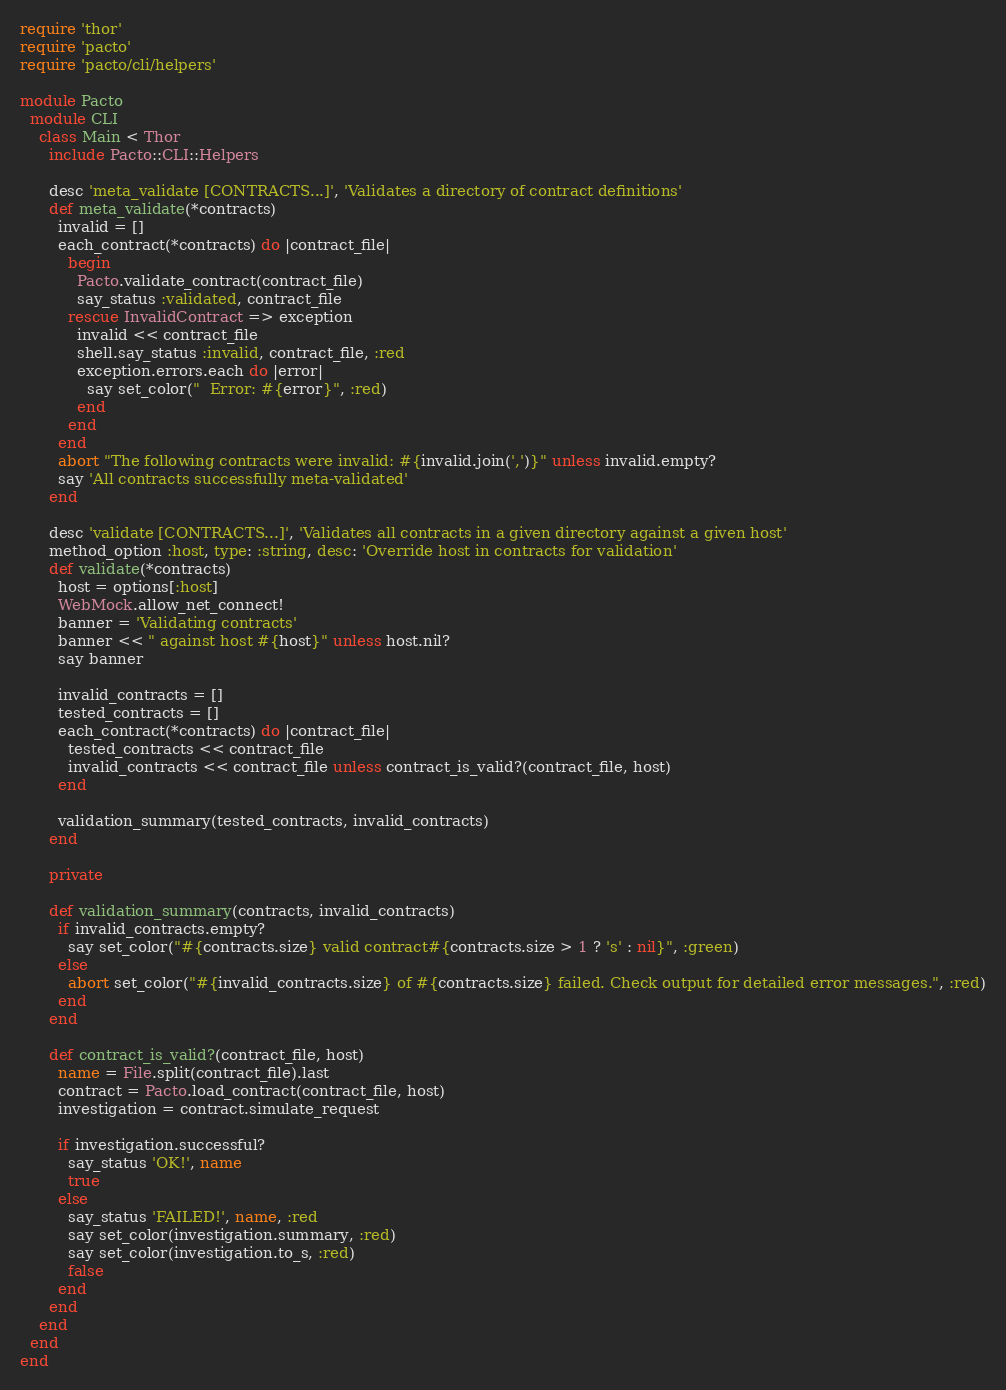Convert code to text. <code><loc_0><loc_0><loc_500><loc_500><_Ruby_>require 'thor'
require 'pacto'
require 'pacto/cli/helpers'

module Pacto
  module CLI
    class Main < Thor
      include Pacto::CLI::Helpers

      desc 'meta_validate [CONTRACTS...]', 'Validates a directory of contract definitions'
      def meta_validate(*contracts)
        invalid = []
        each_contract(*contracts) do |contract_file|
          begin
            Pacto.validate_contract(contract_file)
            say_status :validated, contract_file
          rescue InvalidContract => exception
            invalid << contract_file
            shell.say_status :invalid, contract_file, :red
            exception.errors.each do |error|
              say set_color("  Error: #{error}", :red)
            end
          end
        end
        abort "The following contracts were invalid: #{invalid.join(',')}" unless invalid.empty?
        say 'All contracts successfully meta-validated'
      end

      desc 'validate [CONTRACTS...]', 'Validates all contracts in a given directory against a given host'
      method_option :host, type: :string, desc: 'Override host in contracts for validation'
      def validate(*contracts)
        host = options[:host]
        WebMock.allow_net_connect!
        banner = 'Validating contracts'
        banner << " against host #{host}" unless host.nil?
        say banner

        invalid_contracts = []
        tested_contracts = []
        each_contract(*contracts) do |contract_file|
          tested_contracts << contract_file
          invalid_contracts << contract_file unless contract_is_valid?(contract_file, host)
        end

        validation_summary(tested_contracts, invalid_contracts)
      end

      private

      def validation_summary(contracts, invalid_contracts)
        if invalid_contracts.empty?
          say set_color("#{contracts.size} valid contract#{contracts.size > 1 ? 's' : nil}", :green)
        else
          abort set_color("#{invalid_contracts.size} of #{contracts.size} failed. Check output for detailed error messages.", :red)
        end
      end

      def contract_is_valid?(contract_file, host)
        name = File.split(contract_file).last
        contract = Pacto.load_contract(contract_file, host)
        investigation = contract.simulate_request

        if investigation.successful?
          say_status 'OK!', name
          true
        else
          say_status 'FAILED!', name, :red
          say set_color(investigation.summary, :red)
          say set_color(investigation.to_s, :red)
          false
        end
      end
    end
  end
end
</code> 